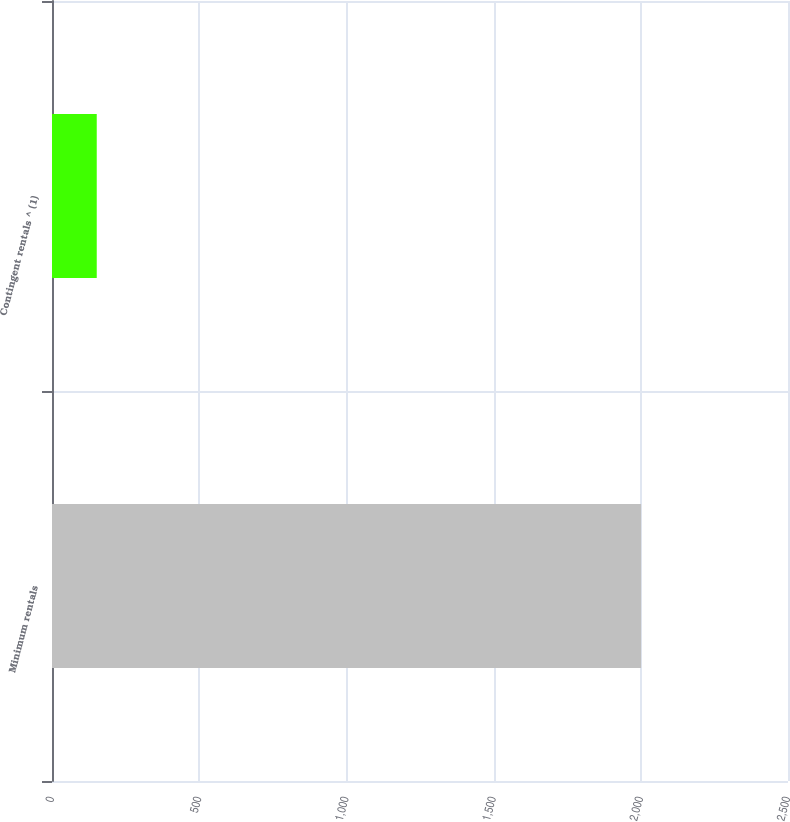Convert chart to OTSL. <chart><loc_0><loc_0><loc_500><loc_500><bar_chart><fcel>Minimum rentals<fcel>Contingent rentals ^ (1)<nl><fcel>2001<fcel>152<nl></chart> 